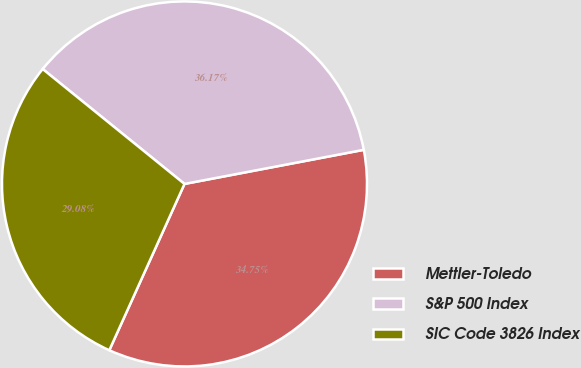Convert chart. <chart><loc_0><loc_0><loc_500><loc_500><pie_chart><fcel>Mettler-Toledo<fcel>S&P 500 Index<fcel>SIC Code 3826 Index<nl><fcel>34.75%<fcel>36.17%<fcel>29.08%<nl></chart> 